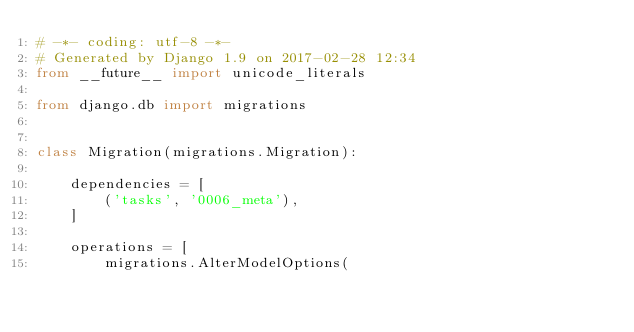Convert code to text. <code><loc_0><loc_0><loc_500><loc_500><_Python_># -*- coding: utf-8 -*-
# Generated by Django 1.9 on 2017-02-28 12:34
from __future__ import unicode_literals

from django.db import migrations


class Migration(migrations.Migration):

    dependencies = [
        ('tasks', '0006_meta'),
    ]

    operations = [
        migrations.AlterModelOptions(</code> 